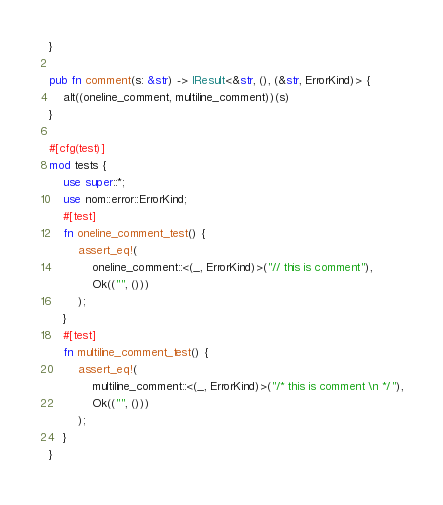<code> <loc_0><loc_0><loc_500><loc_500><_Rust_>}

pub fn comment(s: &str) -> IResult<&str, (), (&str, ErrorKind)> {
    alt((oneline_comment, multiline_comment))(s)
}

#[cfg(test)]
mod tests {
    use super::*;
    use nom::error::ErrorKind;
    #[test]
    fn oneline_comment_test() {
        assert_eq!(
            oneline_comment::<(_, ErrorKind)>("// this is comment"),
            Ok(("", ()))
        );
    }
    #[test]
    fn multiline_comment_test() {
        assert_eq!(
            multiline_comment::<(_, ErrorKind)>("/* this is comment \n */"),
            Ok(("", ()))
        );
    }
}
</code> 